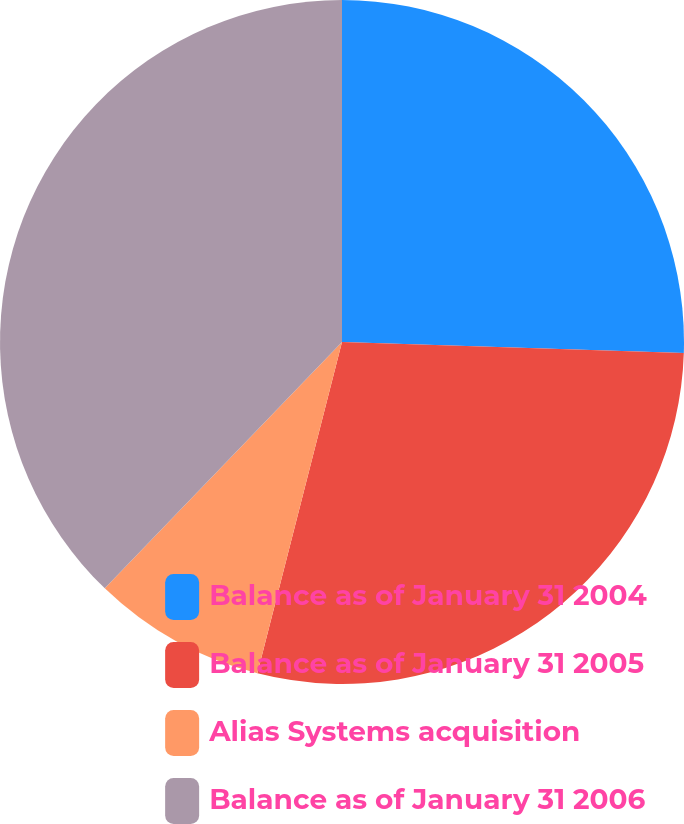<chart> <loc_0><loc_0><loc_500><loc_500><pie_chart><fcel>Balance as of January 31 2004<fcel>Balance as of January 31 2005<fcel>Alias Systems acquisition<fcel>Balance as of January 31 2006<nl><fcel>25.51%<fcel>28.47%<fcel>8.22%<fcel>37.8%<nl></chart> 